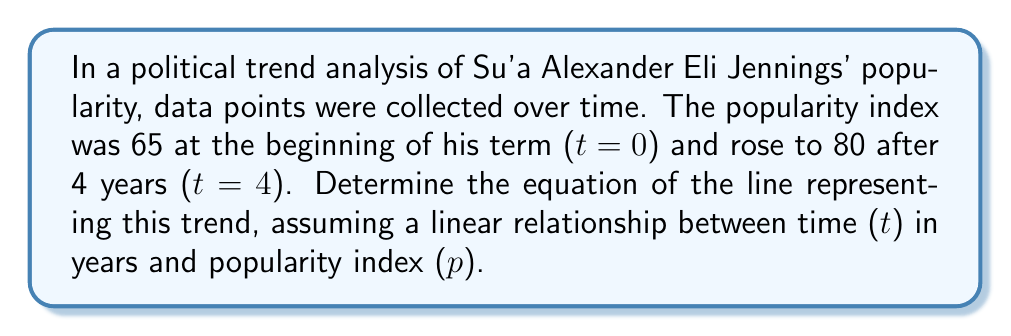What is the answer to this math problem? To find the equation of the line, we'll use the point-slope form: $y - y_1 = m(x - x_1)$, where $m$ is the slope.

1. Identify two points:
   $(x_1, y_1) = (0, 65)$ and $(x_2, y_2) = (4, 80)$

2. Calculate the slope:
   $m = \frac{y_2 - y_1}{x_2 - x_1} = \frac{80 - 65}{4 - 0} = \frac{15}{4} = 3.75$

3. Use the point-slope form with $(x_1, y_1) = (0, 65)$:
   $p - 65 = 3.75(t - 0)$

4. Simplify:
   $p - 65 = 3.75t$

5. Solve for $p$:
   $p = 3.75t + 65$

This equation represents the linear trend of Su'a Alexander Eli Jennings' popularity over time, where $p$ is the popularity index and $t$ is the time in years.
Answer: $p = 3.75t + 65$ 